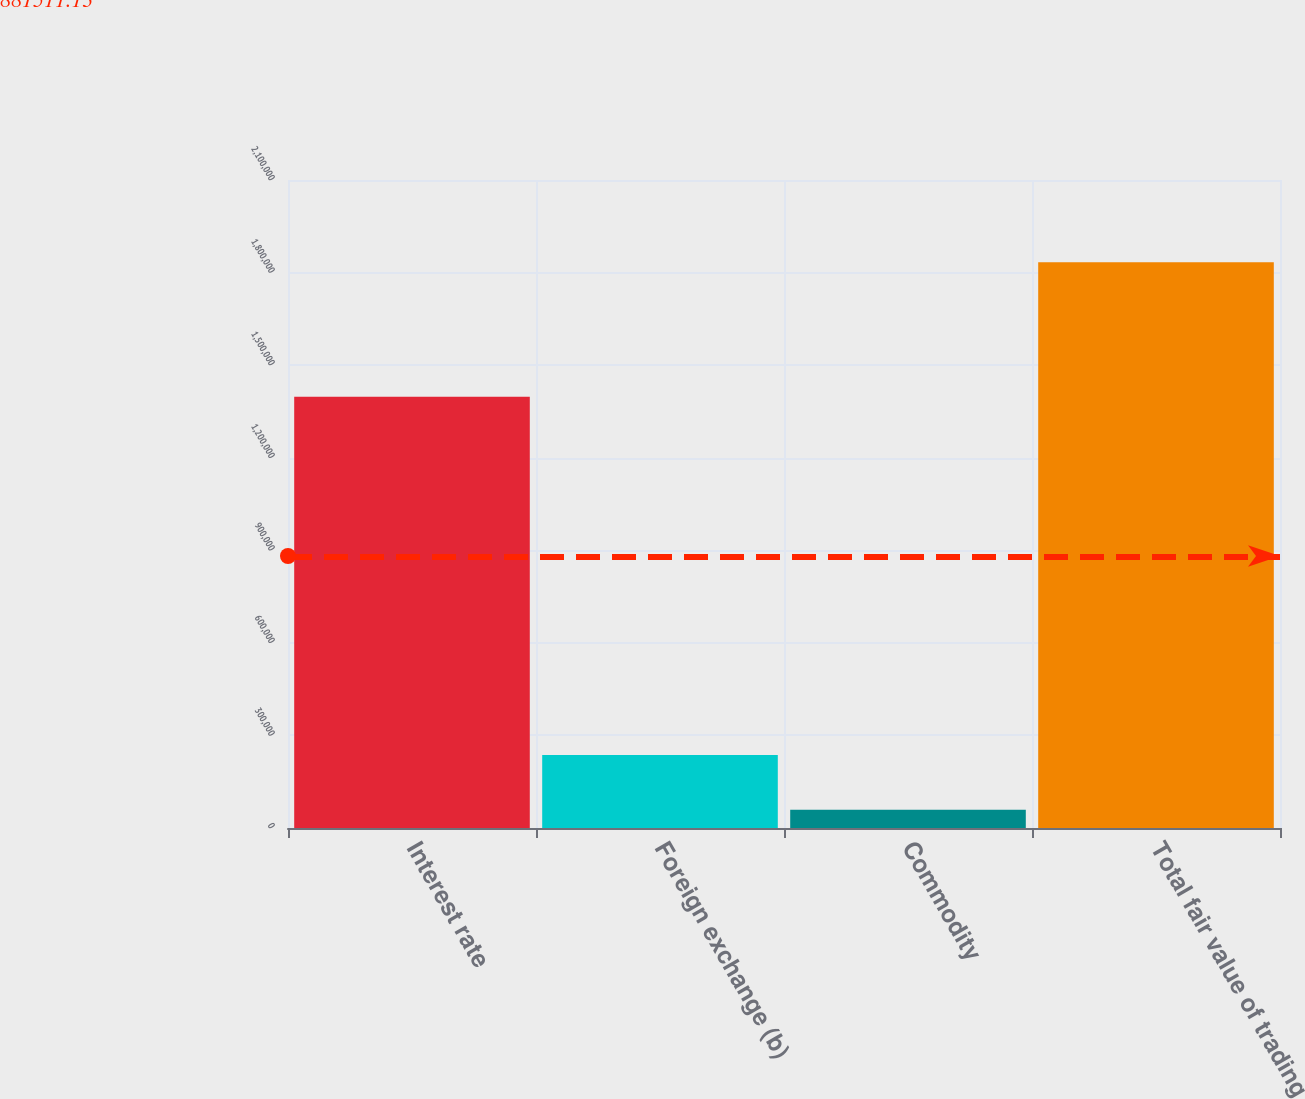<chart> <loc_0><loc_0><loc_500><loc_500><bar_chart><fcel>Interest rate<fcel>Foreign exchange (b)<fcel>Commodity<fcel>Total fair value of trading<nl><fcel>1.39762e+06<fcel>236282<fcel>58836<fcel>1.8333e+06<nl></chart> 